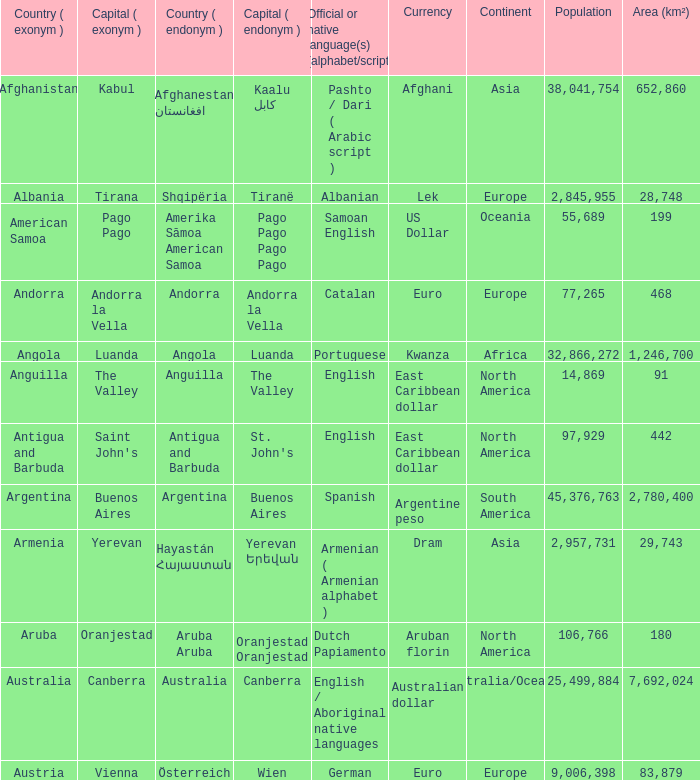What is the local name given to the capital of Anguilla? The Valley. Parse the full table. {'header': ['Country ( exonym )', 'Capital ( exonym )', 'Country ( endonym )', 'Capital ( endonym )', 'Official or native language(s) (alphabet/script)', 'Currency', 'Continent', 'Population', 'Area (km²)'], 'rows': [['Afghanistan', 'Kabul', 'Afghanestan افغانستان', 'Kaalu كابل', 'Pashto / Dari ( Arabic script )', 'Afghani', 'Asia', '38,041,754', '652,860'], ['Albania', 'Tirana', 'Shqipëria', 'Tiranë', 'Albanian', 'Lek', 'Europe', '2,845,955', '28,748'], ['American Samoa', 'Pago Pago', 'Amerika Sāmoa American Samoa', 'Pago Pago Pago Pago', 'Samoan English', 'US Dollar', 'Oceania', '55,689', '199'], ['Andorra', 'Andorra la Vella', 'Andorra', 'Andorra la Vella', 'Catalan', 'Euro', 'Europe', '77,265', '468'], ['Angola', 'Luanda', 'Angola', 'Luanda', 'Portuguese', 'Kwanza', 'Africa', '32,866,272', '1,246,700'], ['Anguilla', 'The Valley', 'Anguilla', 'The Valley', 'English', 'East Caribbean dollar', 'North America', '14,869', '91'], ['Antigua and Barbuda', "Saint John's", 'Antigua and Barbuda', "St. John's", 'English', 'East Caribbean dollar', 'North America', '97,929', '442'], ['Argentina', 'Buenos Aires', 'Argentina', 'Buenos Aires', 'Spanish', 'Argentine peso', 'South America', '45,376,763', '2,780,400'], ['Armenia', 'Yerevan', 'Hayastán Հայաստան', 'Yerevan Երեվան', 'Armenian ( Armenian alphabet )', 'Dram', 'Asia', '2,957,731', '29,743'], ['Aruba', 'Oranjestad', 'Aruba Aruba', 'Oranjestad Oranjestad', 'Dutch Papiamento', 'Aruban florin', 'North America', '106,766', '180'], ['Australia', 'Canberra', 'Australia', 'Canberra', 'English / Aboriginal native languages', 'Australian dollar', 'Australia/Oceania', '25,499,884', '7,692,024'], ['Austria', 'Vienna', 'Österreich', 'Wien', 'German', 'Euro', 'Europe', '9,006,398', '83,879']]} 